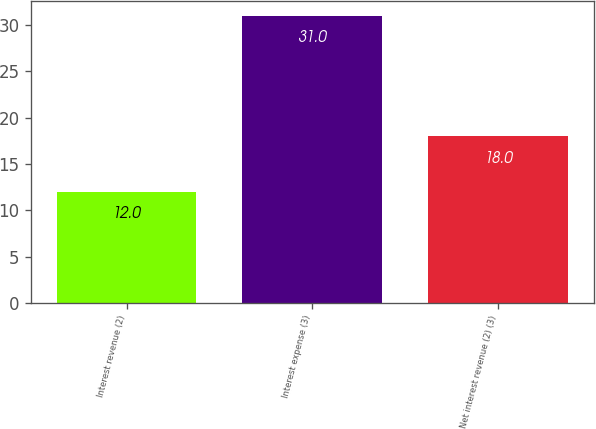Convert chart to OTSL. <chart><loc_0><loc_0><loc_500><loc_500><bar_chart><fcel>Interest revenue (2)<fcel>Interest expense (3)<fcel>Net interest revenue (2) (3)<nl><fcel>12<fcel>31<fcel>18<nl></chart> 